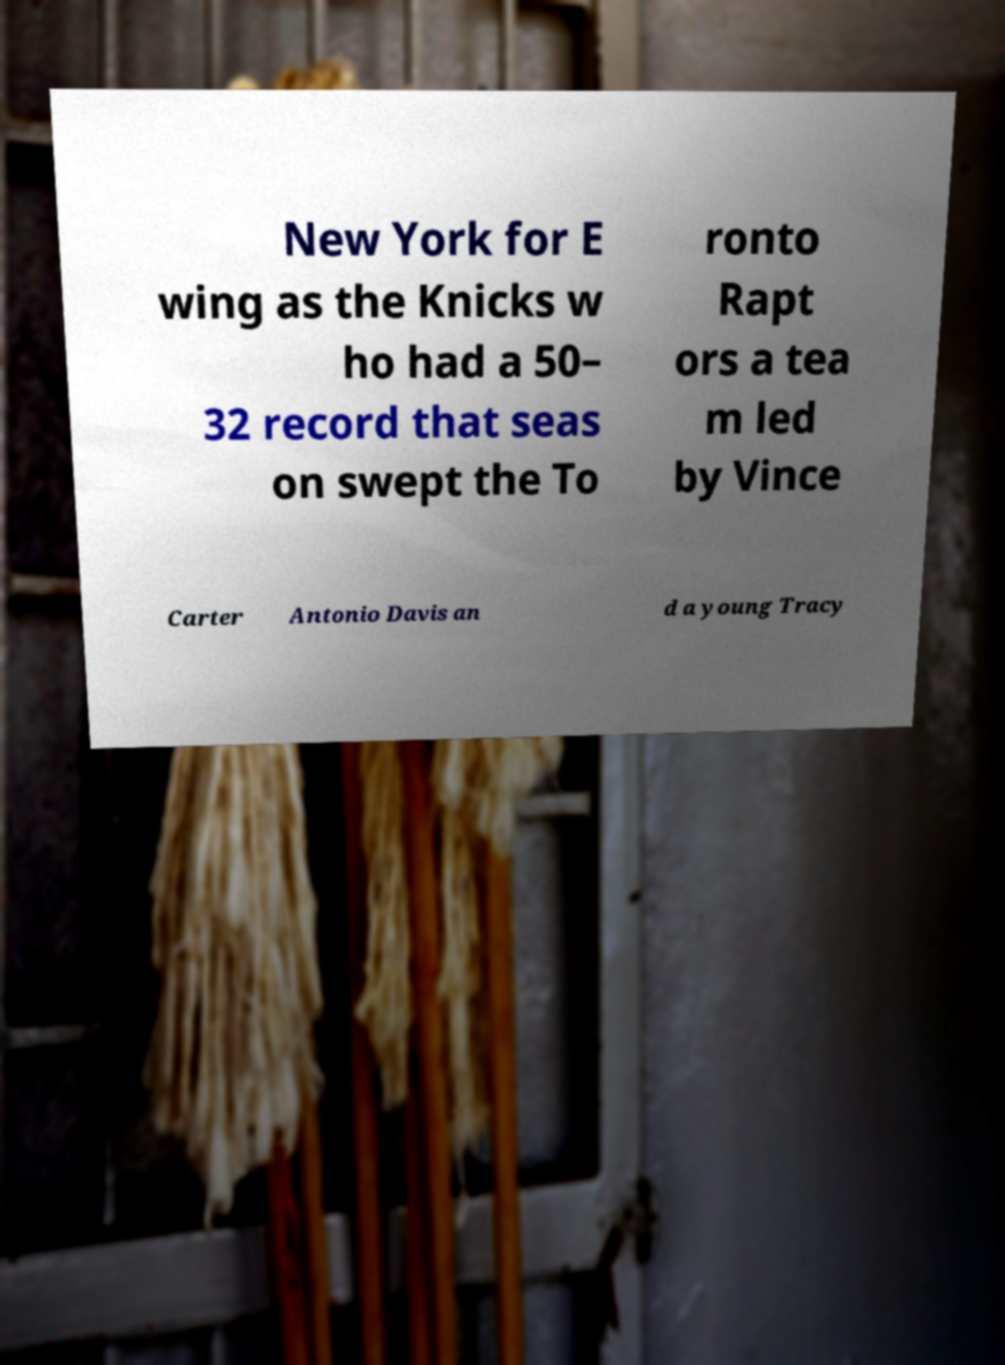Could you extract and type out the text from this image? New York for E wing as the Knicks w ho had a 50– 32 record that seas on swept the To ronto Rapt ors a tea m led by Vince Carter Antonio Davis an d a young Tracy 